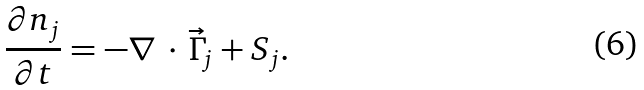Convert formula to latex. <formula><loc_0><loc_0><loc_500><loc_500>\frac { \partial n _ { j } } { \partial t } = - \nabla \, \cdot \, \vec { \Gamma } _ { j } + S _ { j } .</formula> 